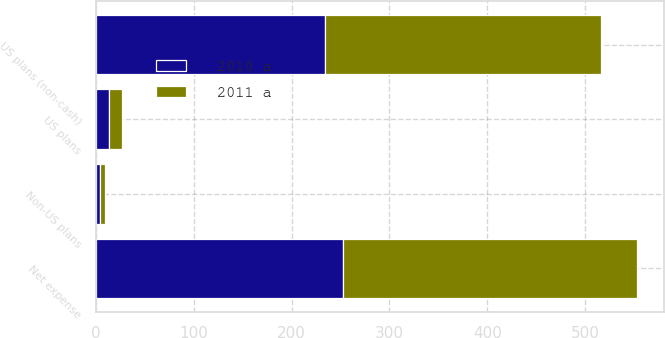Convert chart. <chart><loc_0><loc_0><loc_500><loc_500><stacked_bar_chart><ecel><fcel>US plans (non-cash)<fcel>Non-US plans<fcel>US plans<fcel>Net expense<nl><fcel>2011 a<fcel>282<fcel>5<fcel>13<fcel>301<nl><fcel>2010 a<fcel>234<fcel>4<fcel>13<fcel>252<nl></chart> 